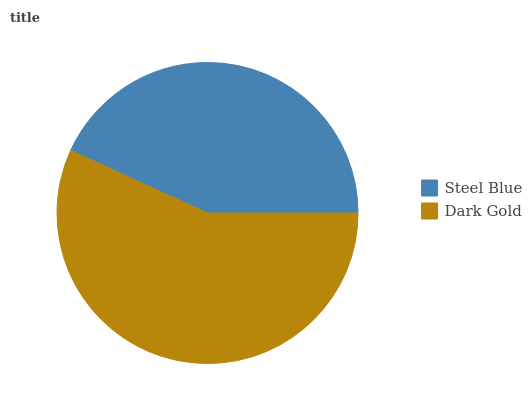Is Steel Blue the minimum?
Answer yes or no. Yes. Is Dark Gold the maximum?
Answer yes or no. Yes. Is Dark Gold the minimum?
Answer yes or no. No. Is Dark Gold greater than Steel Blue?
Answer yes or no. Yes. Is Steel Blue less than Dark Gold?
Answer yes or no. Yes. Is Steel Blue greater than Dark Gold?
Answer yes or no. No. Is Dark Gold less than Steel Blue?
Answer yes or no. No. Is Dark Gold the high median?
Answer yes or no. Yes. Is Steel Blue the low median?
Answer yes or no. Yes. Is Steel Blue the high median?
Answer yes or no. No. Is Dark Gold the low median?
Answer yes or no. No. 